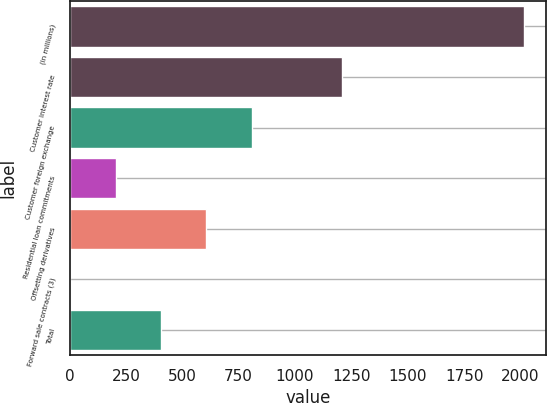Convert chart. <chart><loc_0><loc_0><loc_500><loc_500><bar_chart><fcel>(in millions)<fcel>Customer interest rate<fcel>Customer foreign exchange<fcel>Residential loan commitments<fcel>Offsetting derivatives<fcel>Forward sale contracts (3)<fcel>Total<nl><fcel>2014<fcel>1209.6<fcel>807.4<fcel>204.1<fcel>606.3<fcel>3<fcel>405.2<nl></chart> 